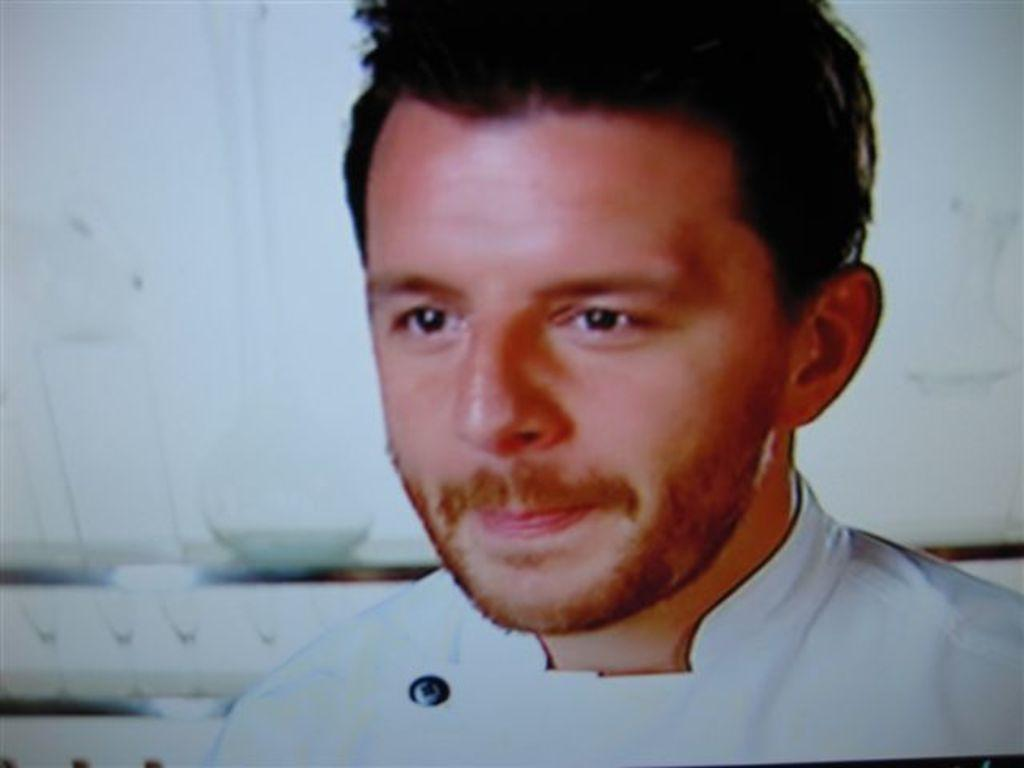What is the person in the image wearing? The person in the image is wearing a white dress. What can be seen in the background of the image? There is a bowl, a jar, and other objects in the background of the image. Can you describe the other objects in the background? Unfortunately, the provided facts do not give specific details about the other objects in the background. What type of force is being applied to the jar in the image? There is no indication of any force being applied to the jar in the image. The jar is simply present in the background. 